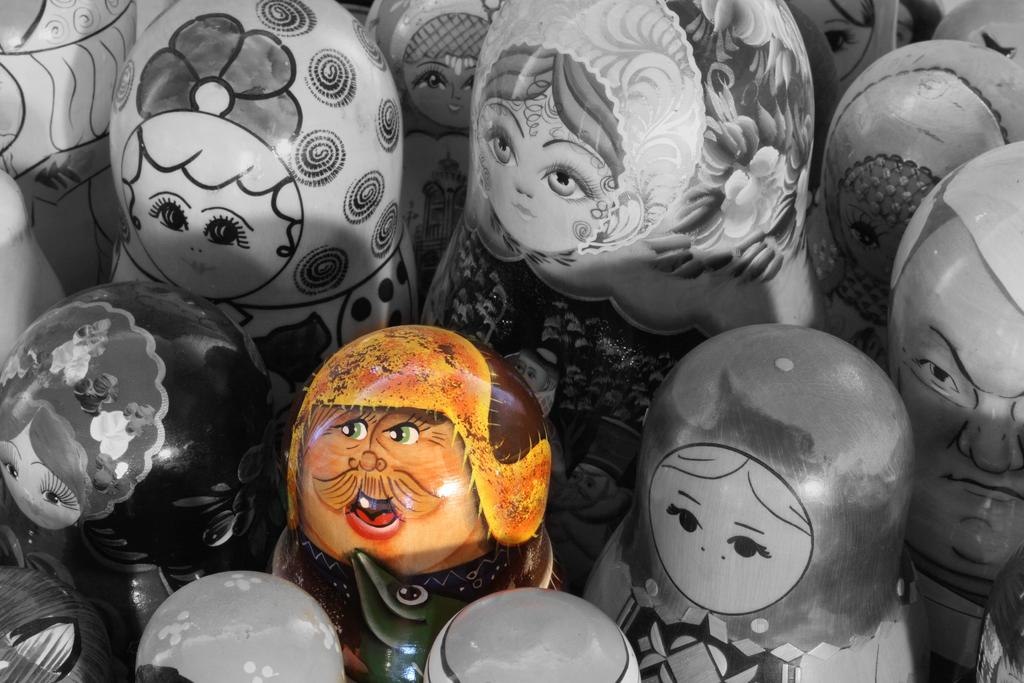What is the main subject of the image? The main subject of the image is a group of figures. What color scheme is used for the figures? The figures are in black and white color. Is there a specific figure that stands out in the group? Yes, there is a figure in the middle of the group. How does the figure in the middle differ from the others? The figure in the middle is in color. How many legs are visible on the beds in the image? There are no beds present in the image; it features a group of figures in black and white color with a figure in the middle that is in color. 